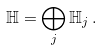<formula> <loc_0><loc_0><loc_500><loc_500>\mathbb { H } = \bigoplus _ { j } \mathbb { H } _ { j } \, .</formula> 